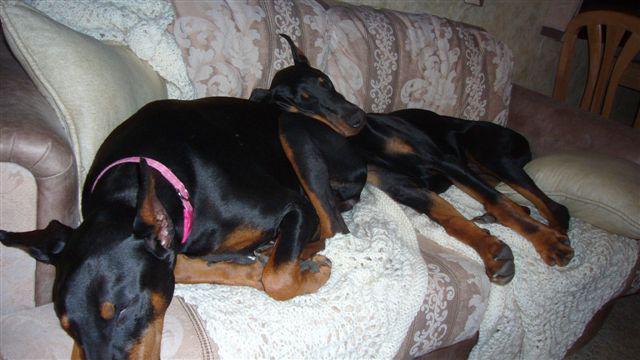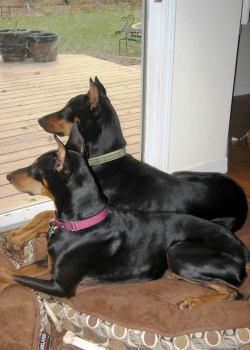The first image is the image on the left, the second image is the image on the right. For the images shown, is this caption "Each image contains two dobermans, and the left image depicts dobermans reclining on a sofa." true? Answer yes or no. Yes. The first image is the image on the left, the second image is the image on the right. For the images displayed, is the sentence "Two dogs are sleeping on a couch in the left image." factually correct? Answer yes or no. Yes. 